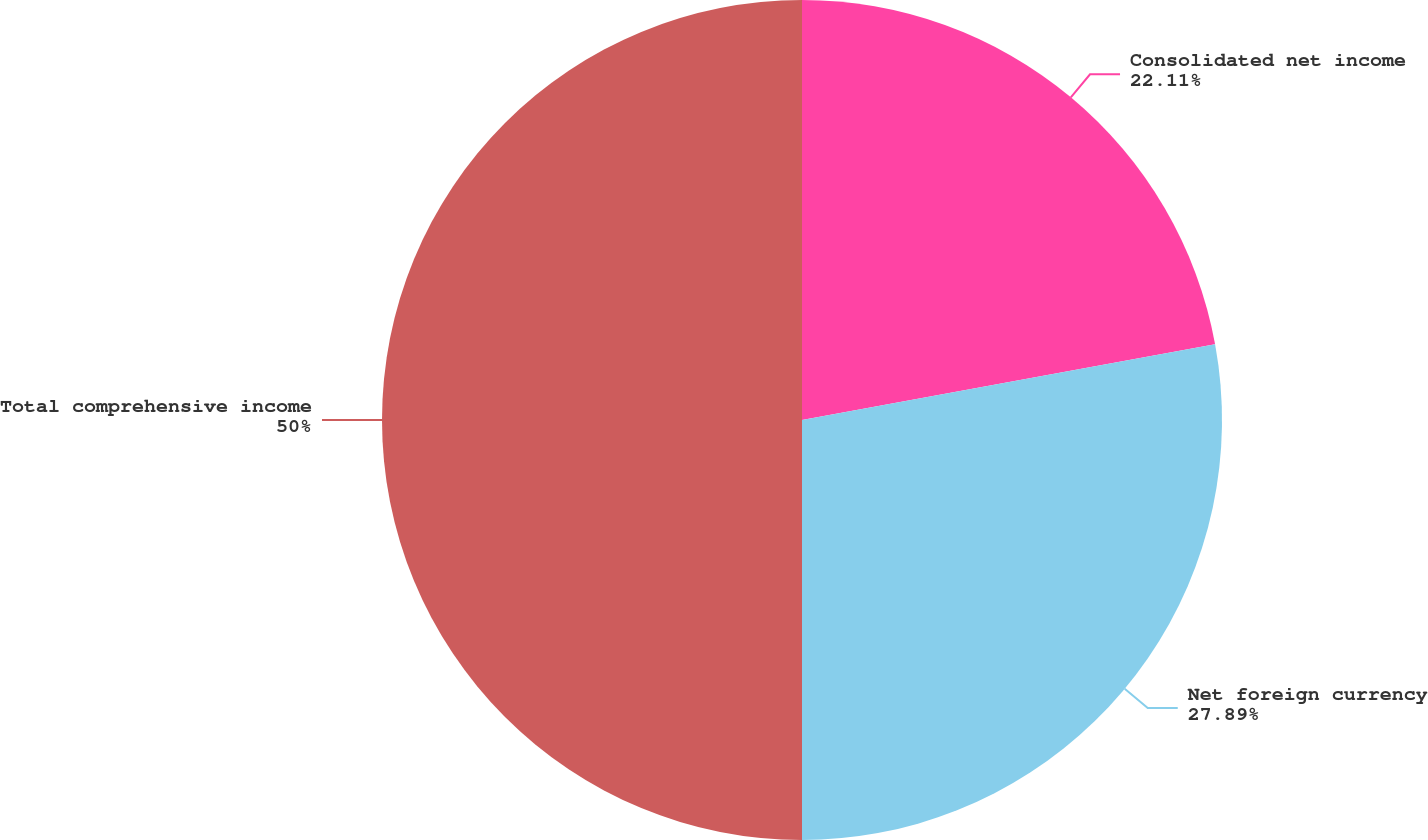<chart> <loc_0><loc_0><loc_500><loc_500><pie_chart><fcel>Consolidated net income<fcel>Net foreign currency<fcel>Total comprehensive income<nl><fcel>22.11%<fcel>27.89%<fcel>50.0%<nl></chart> 